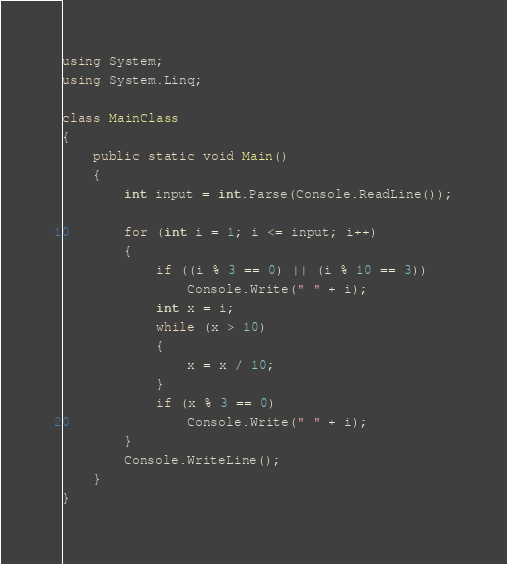<code> <loc_0><loc_0><loc_500><loc_500><_C#_>using System;
using System.Linq;

class MainClass
{
    public static void Main()
    {
        int input = int.Parse(Console.ReadLine());

        for (int i = 1; i <= input; i++)
        {
            if ((i % 3 == 0) || (i % 10 == 3))
                Console.Write(" " + i);
            int x = i;
            while (x > 10)
            {
                x = x / 10;
            }
            if (x % 3 == 0)
                Console.Write(" " + i);
        }
        Console.WriteLine();
    }
}</code> 